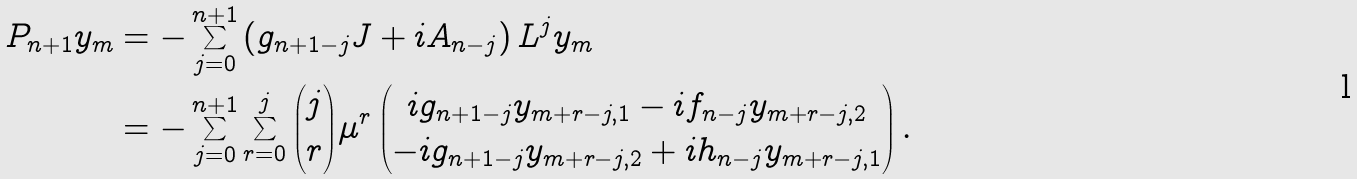Convert formula to latex. <formula><loc_0><loc_0><loc_500><loc_500>P _ { n + 1 } y _ { m } & = - \sum _ { j = 0 } ^ { n + 1 } \left ( g _ { n + 1 - j } J + i A _ { n - j } \right ) L ^ { j } y _ { m } \\ & = - \sum _ { j = 0 } ^ { n + 1 } \sum _ { r = 0 } ^ { j } \binom { j } { r } \mu ^ { r } \begin{pmatrix} i g _ { n + 1 - j } y _ { m + r - j , 1 } - i f _ { n - j } y _ { m + r - j , 2 } \\ - i g _ { n + 1 - j } y _ { m + r - j , 2 } + i h _ { n - j } y _ { m + r - j , 1 } \end{pmatrix} .</formula> 